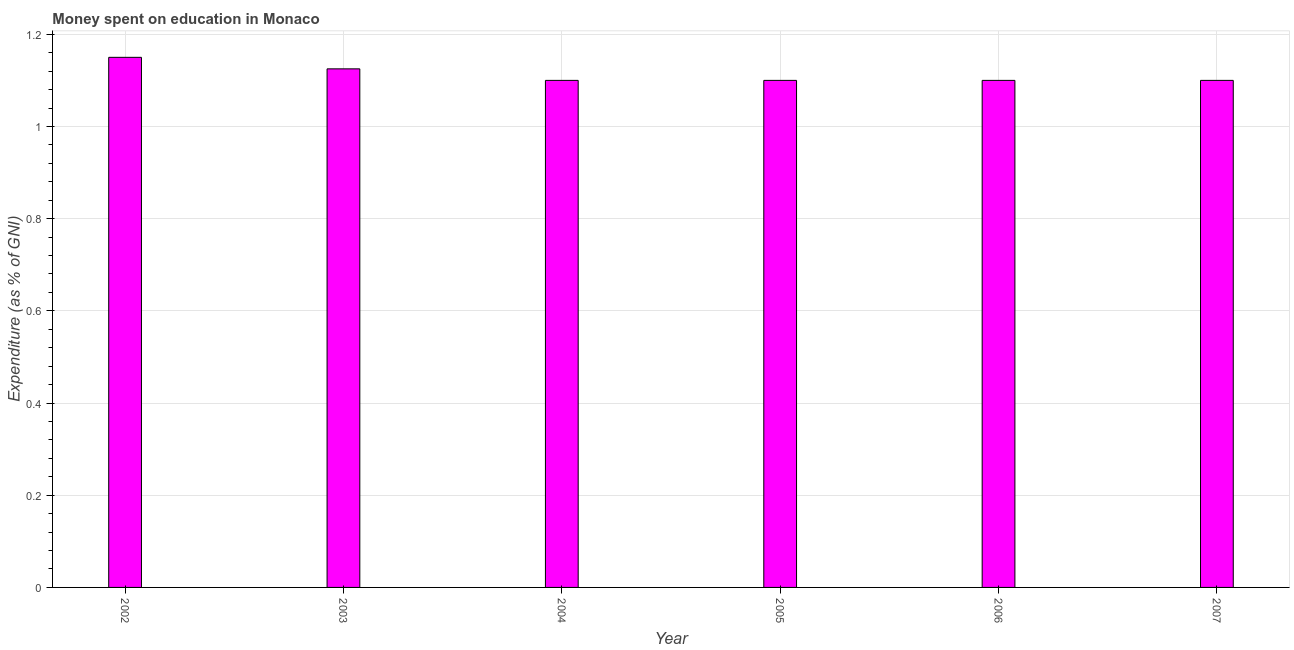Does the graph contain grids?
Provide a succinct answer. Yes. What is the title of the graph?
Keep it short and to the point. Money spent on education in Monaco. What is the label or title of the Y-axis?
Offer a very short reply. Expenditure (as % of GNI). What is the expenditure on education in 2007?
Your answer should be compact. 1.1. Across all years, what is the maximum expenditure on education?
Your response must be concise. 1.15. What is the sum of the expenditure on education?
Your response must be concise. 6.67. What is the difference between the expenditure on education in 2005 and 2006?
Your answer should be compact. 0. What is the average expenditure on education per year?
Your answer should be compact. 1.11. What is the median expenditure on education?
Provide a short and direct response. 1.1. In how many years, is the expenditure on education greater than 0.44 %?
Make the answer very short. 6. What is the difference between the highest and the second highest expenditure on education?
Keep it short and to the point. 0.03. Is the sum of the expenditure on education in 2002 and 2006 greater than the maximum expenditure on education across all years?
Your answer should be compact. Yes. What is the difference between the highest and the lowest expenditure on education?
Provide a short and direct response. 0.05. In how many years, is the expenditure on education greater than the average expenditure on education taken over all years?
Give a very brief answer. 2. Are all the bars in the graph horizontal?
Provide a short and direct response. No. How many years are there in the graph?
Provide a succinct answer. 6. What is the difference between two consecutive major ticks on the Y-axis?
Offer a very short reply. 0.2. Are the values on the major ticks of Y-axis written in scientific E-notation?
Provide a succinct answer. No. What is the Expenditure (as % of GNI) of 2002?
Provide a short and direct response. 1.15. What is the Expenditure (as % of GNI) in 2004?
Provide a short and direct response. 1.1. What is the Expenditure (as % of GNI) of 2006?
Give a very brief answer. 1.1. What is the Expenditure (as % of GNI) of 2007?
Give a very brief answer. 1.1. What is the difference between the Expenditure (as % of GNI) in 2002 and 2003?
Provide a short and direct response. 0.03. What is the difference between the Expenditure (as % of GNI) in 2002 and 2007?
Your response must be concise. 0.05. What is the difference between the Expenditure (as % of GNI) in 2003 and 2004?
Offer a very short reply. 0.03. What is the difference between the Expenditure (as % of GNI) in 2003 and 2005?
Your answer should be compact. 0.03. What is the difference between the Expenditure (as % of GNI) in 2003 and 2006?
Provide a succinct answer. 0.03. What is the difference between the Expenditure (as % of GNI) in 2003 and 2007?
Your response must be concise. 0.03. What is the difference between the Expenditure (as % of GNI) in 2004 and 2007?
Provide a short and direct response. 0. What is the difference between the Expenditure (as % of GNI) in 2006 and 2007?
Provide a succinct answer. 0. What is the ratio of the Expenditure (as % of GNI) in 2002 to that in 2003?
Give a very brief answer. 1.02. What is the ratio of the Expenditure (as % of GNI) in 2002 to that in 2004?
Offer a terse response. 1.04. What is the ratio of the Expenditure (as % of GNI) in 2002 to that in 2005?
Offer a very short reply. 1.04. What is the ratio of the Expenditure (as % of GNI) in 2002 to that in 2006?
Your answer should be compact. 1.04. What is the ratio of the Expenditure (as % of GNI) in 2002 to that in 2007?
Ensure brevity in your answer.  1.04. What is the ratio of the Expenditure (as % of GNI) in 2003 to that in 2004?
Provide a short and direct response. 1.02. What is the ratio of the Expenditure (as % of GNI) in 2004 to that in 2005?
Your response must be concise. 1. What is the ratio of the Expenditure (as % of GNI) in 2004 to that in 2007?
Give a very brief answer. 1. What is the ratio of the Expenditure (as % of GNI) in 2005 to that in 2006?
Offer a very short reply. 1. What is the ratio of the Expenditure (as % of GNI) in 2005 to that in 2007?
Your answer should be compact. 1. What is the ratio of the Expenditure (as % of GNI) in 2006 to that in 2007?
Offer a very short reply. 1. 